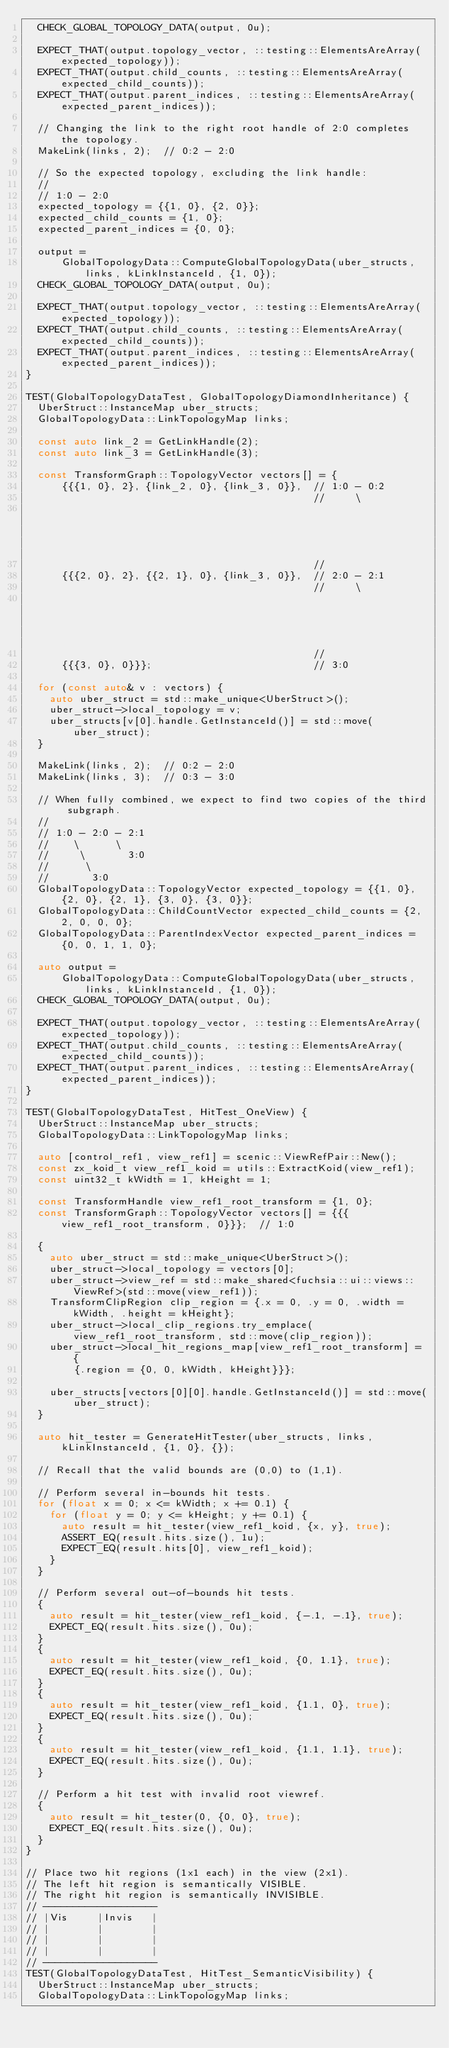<code> <loc_0><loc_0><loc_500><loc_500><_C++_>  CHECK_GLOBAL_TOPOLOGY_DATA(output, 0u);

  EXPECT_THAT(output.topology_vector, ::testing::ElementsAreArray(expected_topology));
  EXPECT_THAT(output.child_counts, ::testing::ElementsAreArray(expected_child_counts));
  EXPECT_THAT(output.parent_indices, ::testing::ElementsAreArray(expected_parent_indices));

  // Changing the link to the right root handle of 2:0 completes the topology.
  MakeLink(links, 2);  // 0:2 - 2:0

  // So the expected topology, excluding the link handle:
  //
  // 1:0 - 2:0
  expected_topology = {{1, 0}, {2, 0}};
  expected_child_counts = {1, 0};
  expected_parent_indices = {0, 0};

  output =
      GlobalTopologyData::ComputeGlobalTopologyData(uber_structs, links, kLinkInstanceId, {1, 0});
  CHECK_GLOBAL_TOPOLOGY_DATA(output, 0u);

  EXPECT_THAT(output.topology_vector, ::testing::ElementsAreArray(expected_topology));
  EXPECT_THAT(output.child_counts, ::testing::ElementsAreArray(expected_child_counts));
  EXPECT_THAT(output.parent_indices, ::testing::ElementsAreArray(expected_parent_indices));
}

TEST(GlobalTopologyDataTest, GlobalTopologyDiamondInheritance) {
  UberStruct::InstanceMap uber_structs;
  GlobalTopologyData::LinkTopologyMap links;

  const auto link_2 = GetLinkHandle(2);
  const auto link_3 = GetLinkHandle(3);

  const TransformGraph::TopologyVector vectors[] = {
      {{{1, 0}, 2}, {link_2, 0}, {link_3, 0}},  // 1:0 - 0:2
                                                //     \
                                                                                        //       0:3
                                                //
      {{{2, 0}, 2}, {{2, 1}, 0}, {link_3, 0}},  // 2:0 - 2:1
                                                //     \
                                                                                        //       0:3
                                                //
      {{{3, 0}, 0}}};                           // 3:0

  for (const auto& v : vectors) {
    auto uber_struct = std::make_unique<UberStruct>();
    uber_struct->local_topology = v;
    uber_structs[v[0].handle.GetInstanceId()] = std::move(uber_struct);
  }

  MakeLink(links, 2);  // 0:2 - 2:0
  MakeLink(links, 3);  // 0:3 - 3:0

  // When fully combined, we expect to find two copies of the third subgraph.
  //
  // 1:0 - 2:0 - 2:1
  //    \      \
  //     \       3:0
  //      \
  //       3:0
  GlobalTopologyData::TopologyVector expected_topology = {{1, 0}, {2, 0}, {2, 1}, {3, 0}, {3, 0}};
  GlobalTopologyData::ChildCountVector expected_child_counts = {2, 2, 0, 0, 0};
  GlobalTopologyData::ParentIndexVector expected_parent_indices = {0, 0, 1, 1, 0};

  auto output =
      GlobalTopologyData::ComputeGlobalTopologyData(uber_structs, links, kLinkInstanceId, {1, 0});
  CHECK_GLOBAL_TOPOLOGY_DATA(output, 0u);

  EXPECT_THAT(output.topology_vector, ::testing::ElementsAreArray(expected_topology));
  EXPECT_THAT(output.child_counts, ::testing::ElementsAreArray(expected_child_counts));
  EXPECT_THAT(output.parent_indices, ::testing::ElementsAreArray(expected_parent_indices));
}

TEST(GlobalTopologyDataTest, HitTest_OneView) {
  UberStruct::InstanceMap uber_structs;
  GlobalTopologyData::LinkTopologyMap links;

  auto [control_ref1, view_ref1] = scenic::ViewRefPair::New();
  const zx_koid_t view_ref1_koid = utils::ExtractKoid(view_ref1);
  const uint32_t kWidth = 1, kHeight = 1;

  const TransformHandle view_ref1_root_transform = {1, 0};
  const TransformGraph::TopologyVector vectors[] = {{{view_ref1_root_transform, 0}}};  // 1:0

  {
    auto uber_struct = std::make_unique<UberStruct>();
    uber_struct->local_topology = vectors[0];
    uber_struct->view_ref = std::make_shared<fuchsia::ui::views::ViewRef>(std::move(view_ref1));
    TransformClipRegion clip_region = {.x = 0, .y = 0, .width = kWidth, .height = kHeight};
    uber_struct->local_clip_regions.try_emplace(view_ref1_root_transform, std::move(clip_region));
    uber_struct->local_hit_regions_map[view_ref1_root_transform] = {
        {.region = {0, 0, kWidth, kHeight}}};

    uber_structs[vectors[0][0].handle.GetInstanceId()] = std::move(uber_struct);
  }

  auto hit_tester = GenerateHitTester(uber_structs, links, kLinkInstanceId, {1, 0}, {});

  // Recall that the valid bounds are (0,0) to (1,1).

  // Perform several in-bounds hit tests.
  for (float x = 0; x <= kWidth; x += 0.1) {
    for (float y = 0; y <= kHeight; y += 0.1) {
      auto result = hit_tester(view_ref1_koid, {x, y}, true);
      ASSERT_EQ(result.hits.size(), 1u);
      EXPECT_EQ(result.hits[0], view_ref1_koid);
    }
  }

  // Perform several out-of-bounds hit tests.
  {
    auto result = hit_tester(view_ref1_koid, {-.1, -.1}, true);
    EXPECT_EQ(result.hits.size(), 0u);
  }
  {
    auto result = hit_tester(view_ref1_koid, {0, 1.1}, true);
    EXPECT_EQ(result.hits.size(), 0u);
  }
  {
    auto result = hit_tester(view_ref1_koid, {1.1, 0}, true);
    EXPECT_EQ(result.hits.size(), 0u);
  }
  {
    auto result = hit_tester(view_ref1_koid, {1.1, 1.1}, true);
    EXPECT_EQ(result.hits.size(), 0u);
  }

  // Perform a hit test with invalid root viewref.
  {
    auto result = hit_tester(0, {0, 0}, true);
    EXPECT_EQ(result.hits.size(), 0u);
  }
}

// Place two hit regions (1x1 each) in the view (2x1).
// The left hit region is semantically VISIBLE.
// The right hit region is semantically INVISIBLE.
// -------------------
// |Vis     |Invis   |
// |        |        |
// |        |        |
// |        |        |
// -------------------
TEST(GlobalTopologyDataTest, HitTest_SemanticVisibility) {
  UberStruct::InstanceMap uber_structs;
  GlobalTopologyData::LinkTopologyMap links;
</code> 